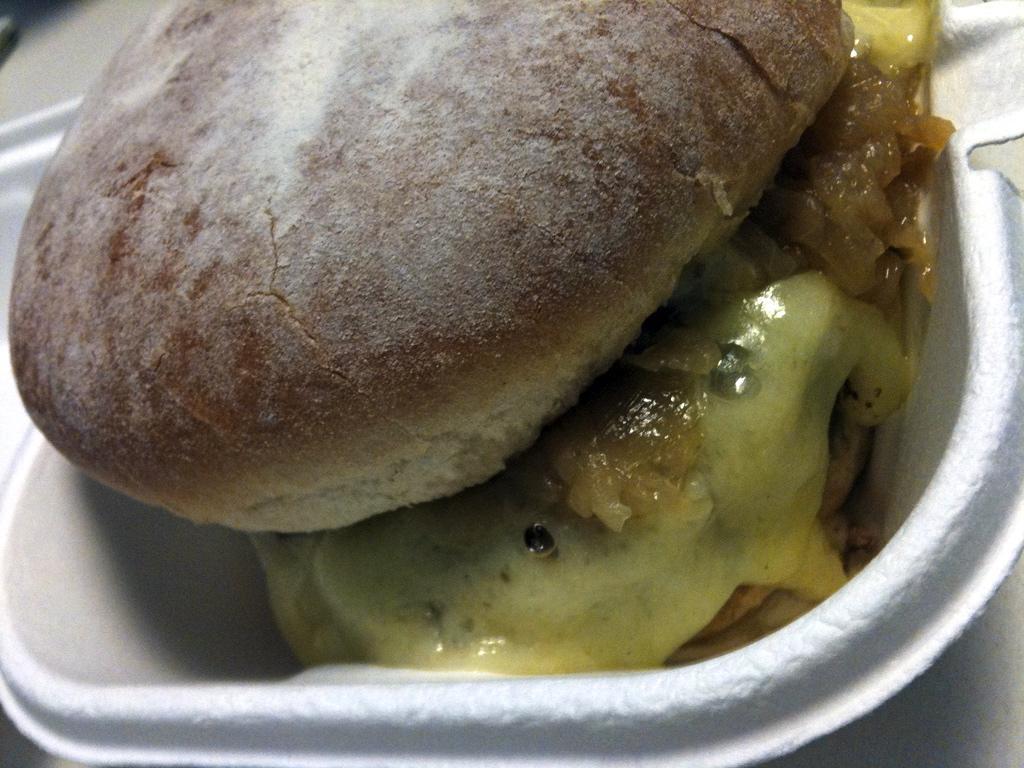Can you describe this image briefly? In this picture we can see some food items. It looks like these food items are in a white bowl. 